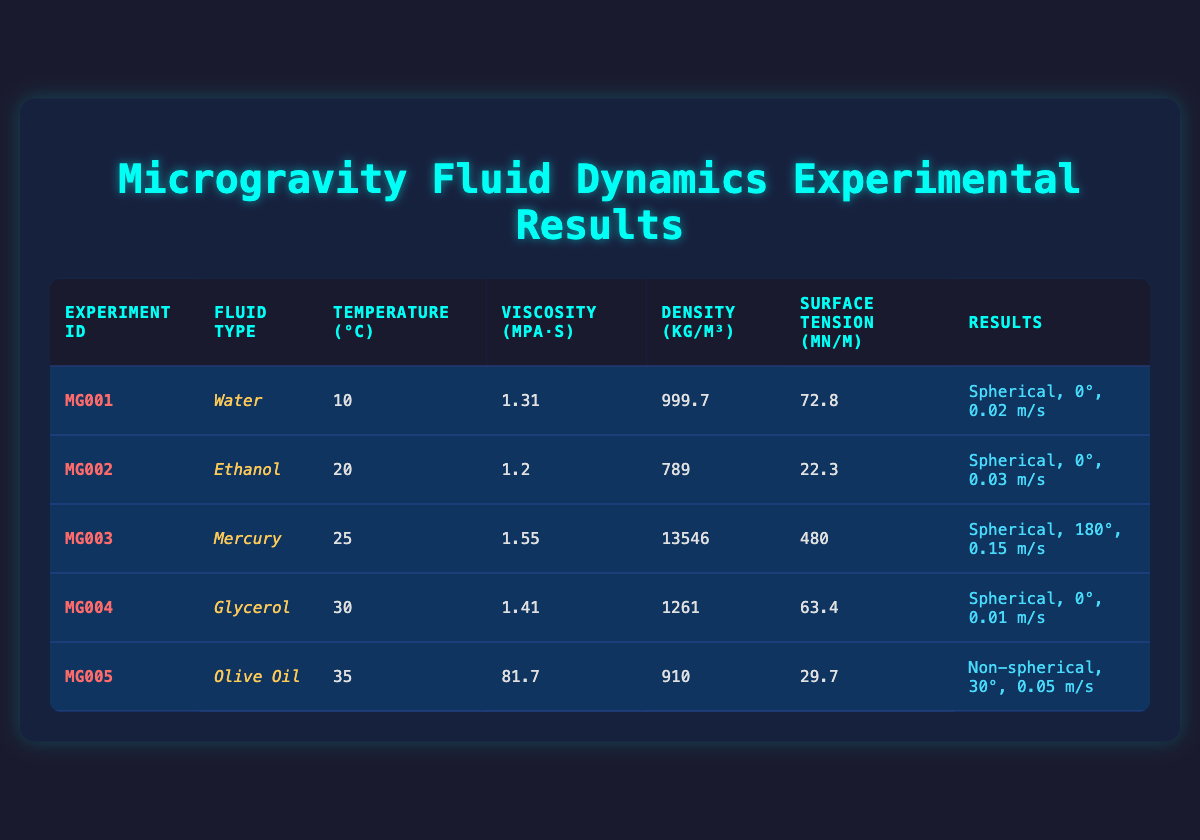What is the viscosity of Ethanol at 20 degrees Celsius? Looking at the table, we can see the row corresponding to Ethanol which lists its viscosity as 1.2 mPa·s.
Answer: 1.2 mPa·s What experimental result corresponds to the fluid type Glycerol? In the row for Glycerol, the results indicate a drop shape of "spherical," a contact angle of 0 degrees, and a settling velocity of 0.01 m/s.
Answer: Spherical, 0°, 0.01 m/s Is the density of Mercury greater than that of Olive Oil? Looking at the density values, Mercury has a density of 13546 kg/m³ while Olive Oil has a density of 910 kg/m³. Since 13546 is greater than 910, the statement is true.
Answer: Yes What is the average temperature of the fluids tested? To find the average temperature, we sum the temperatures: 10 + 20 + 25 + 30 + 35 = 120 and then divide by the number of experiments (5). Thus, the average is 120/5 = 24.
Answer: 24 Which fluid has the highest surface tension? By comparing the surface tension values in the table, Mercury has 480 mN/m, which is higher than the surface tensions of Water, Ethanol, Glycerol, and Olive Oil. Therefore, Mercury has the highest surface tension.
Answer: Mercury How does the settling velocity of Olive Oil compare to that of Water? The settling velocity of Olive Oil is 0.05 m/s, while the settling velocity of Water is 0.02 m/s. When comparing the two, 0.05 m/s is greater than 0.02 m/s, indicating that Olive Oil has a higher settling velocity.
Answer: Olive Oil has a higher settling velocity Does Glycerol exhibit a contact angle of 180 degrees? Checking the table, Glycerol's contact angle is stated as 0 degrees, not 180 degrees, so the statement is false.
Answer: No What is the difference in viscosity between the fluids Water and Mercury? The viscosity of Water is 1.31 mPa·s while that of Mercury is 1.55 mPa·s. To find the difference, we subtract: 1.55 - 1.31 = 0.24 mPa·s.
Answer: 0.24 mPa·s 